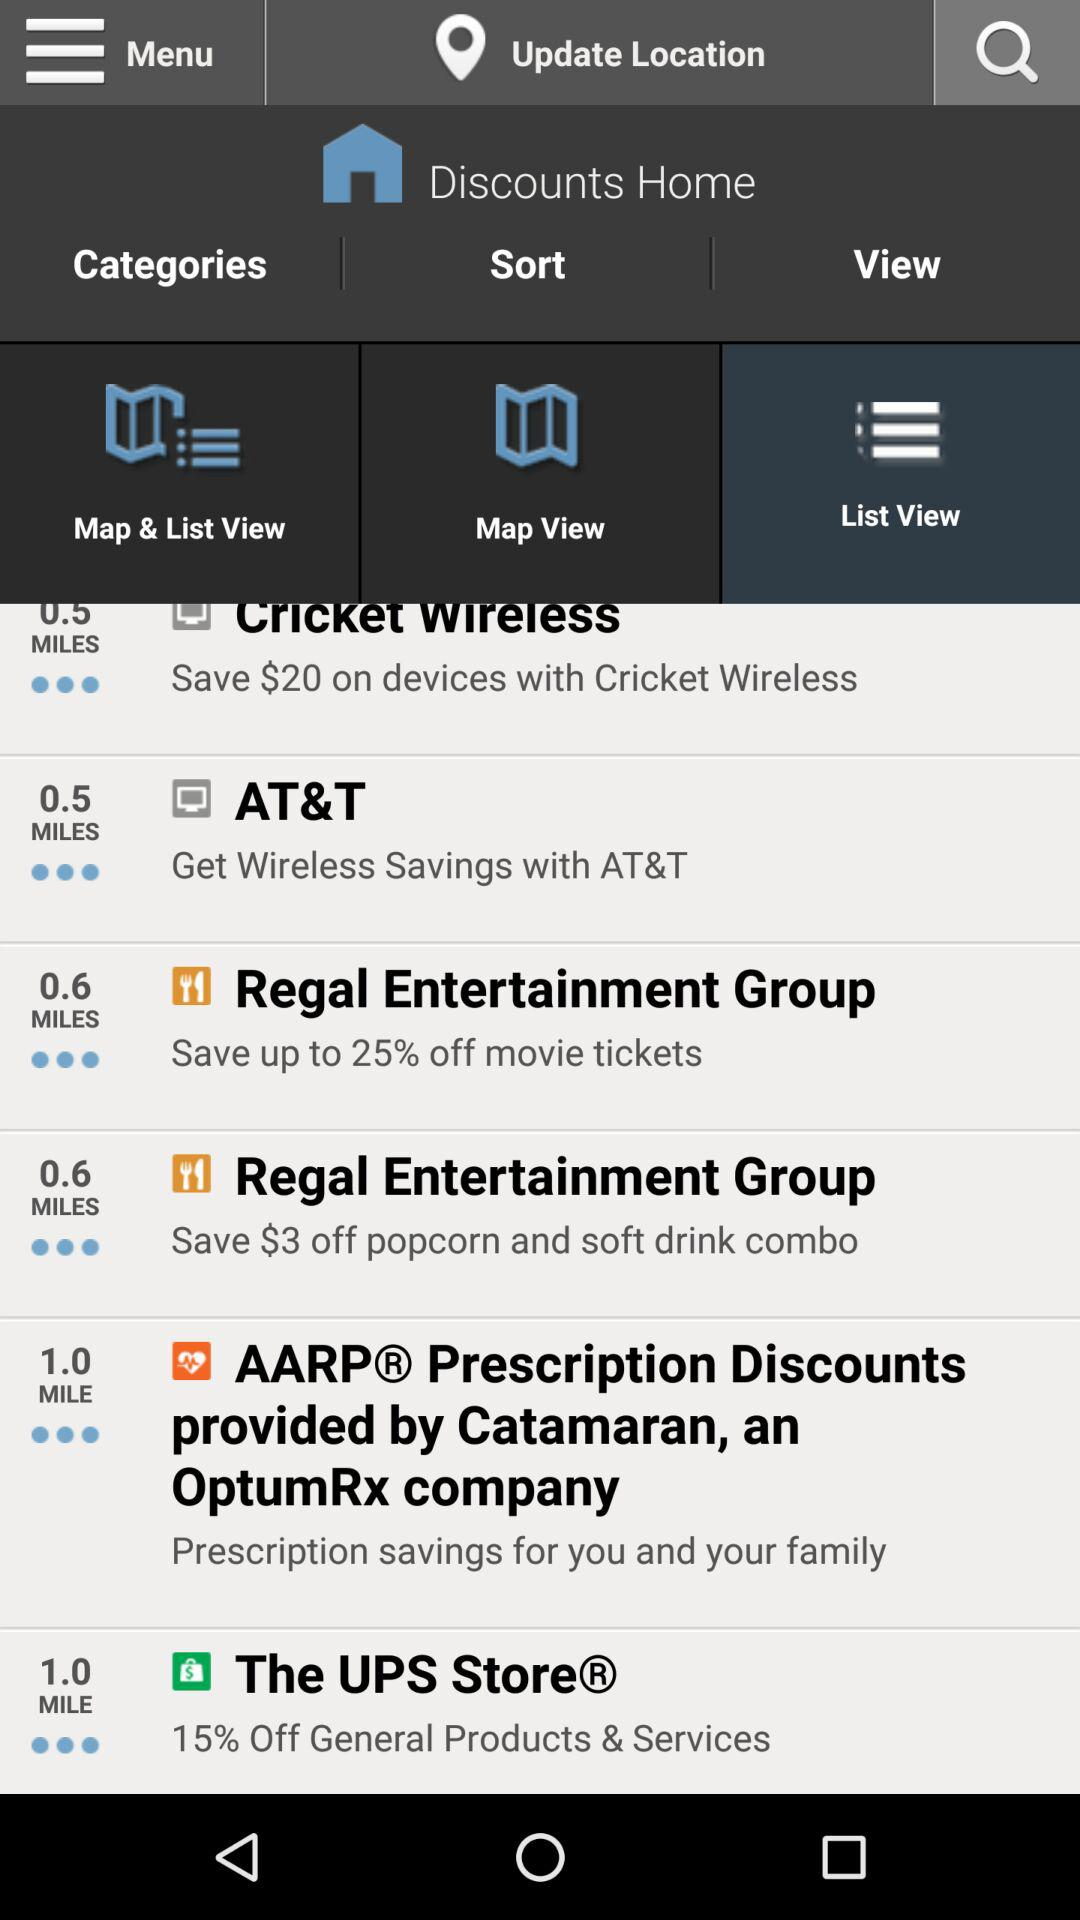How many miles away is the closest discount?
Answer the question using a single word or phrase. 0.5 miles 